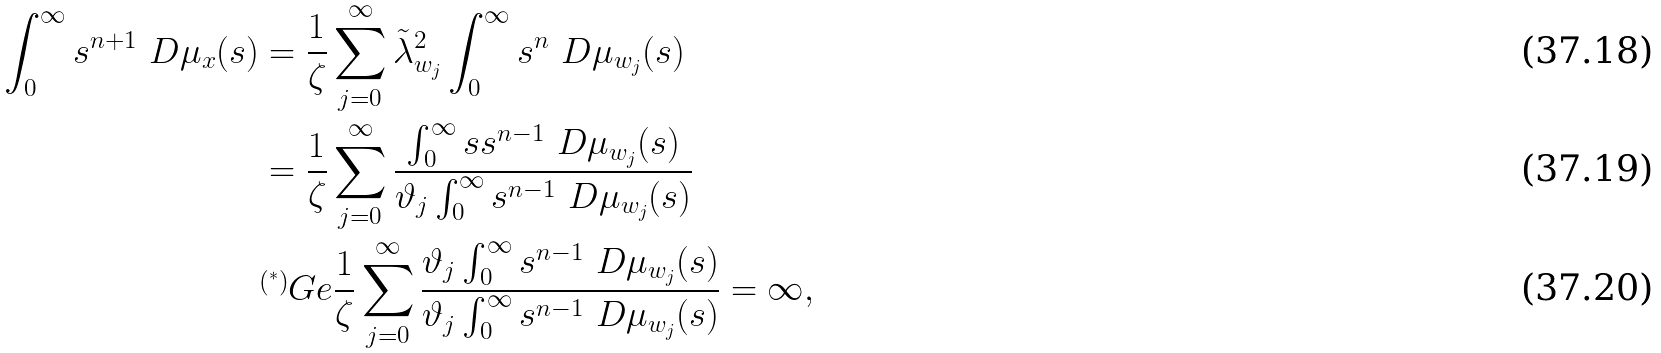<formula> <loc_0><loc_0><loc_500><loc_500>\int _ { 0 } ^ { \infty } s ^ { n + 1 } \ D \mu _ { x } ( s ) & = \frac { 1 } { \zeta } \sum _ { j = 0 } ^ { \infty } \tilde { \lambda } _ { w _ { j } } ^ { 2 } \int _ { 0 } ^ { \infty } s ^ { n } \ D \mu _ { w _ { j } } ( s ) \\ & = \frac { 1 } { \zeta } \sum _ { j = 0 } ^ { \infty } \frac { \int _ { 0 } ^ { \infty } s s ^ { n - 1 } \ D \mu _ { w _ { j } } ( s ) } { \vartheta _ { j } \int _ { 0 } ^ { \infty } s ^ { n - 1 } \ D \mu _ { w _ { j } } ( s ) } \\ & \overset { ( ^ { * } ) } \ G e \frac { 1 } { \zeta } \sum _ { j = 0 } ^ { \infty } \frac { \vartheta _ { j } \int _ { 0 } ^ { \infty } s ^ { n - 1 } \ D \mu _ { w _ { j } } ( s ) } { \vartheta _ { j } \int _ { 0 } ^ { \infty } s ^ { n - 1 } \ D \mu _ { w _ { j } } ( s ) } = \infty ,</formula> 